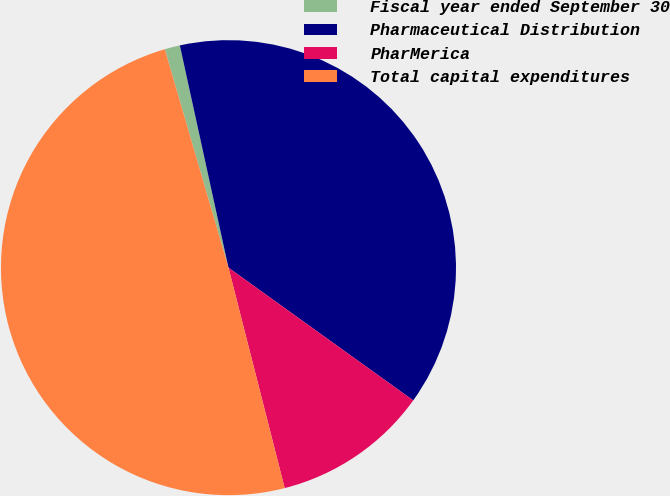Convert chart to OTSL. <chart><loc_0><loc_0><loc_500><loc_500><pie_chart><fcel>Fiscal year ended September 30<fcel>Pharmaceutical Distribution<fcel>PharMerica<fcel>Total capital expenditures<nl><fcel>1.09%<fcel>38.34%<fcel>11.11%<fcel>49.45%<nl></chart> 